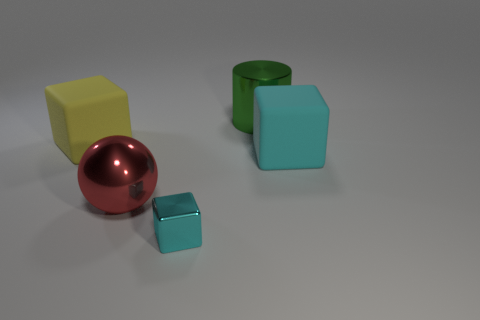Subtract all cyan blocks. How many blocks are left? 1 Add 5 tiny shiny objects. How many objects exist? 10 Subtract all yellow blocks. How many blocks are left? 2 Subtract all cylinders. How many objects are left? 4 Subtract all brown spheres. How many yellow blocks are left? 1 Subtract all small cyan metal cubes. Subtract all red balls. How many objects are left? 3 Add 3 large objects. How many large objects are left? 7 Add 3 small shiny blocks. How many small shiny blocks exist? 4 Subtract 0 gray cylinders. How many objects are left? 5 Subtract 1 cylinders. How many cylinders are left? 0 